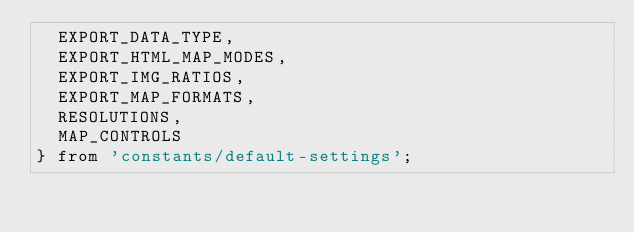Convert code to text. <code><loc_0><loc_0><loc_500><loc_500><_JavaScript_>  EXPORT_DATA_TYPE,
  EXPORT_HTML_MAP_MODES,
  EXPORT_IMG_RATIOS,
  EXPORT_MAP_FORMATS,
  RESOLUTIONS,
  MAP_CONTROLS
} from 'constants/default-settings';</code> 